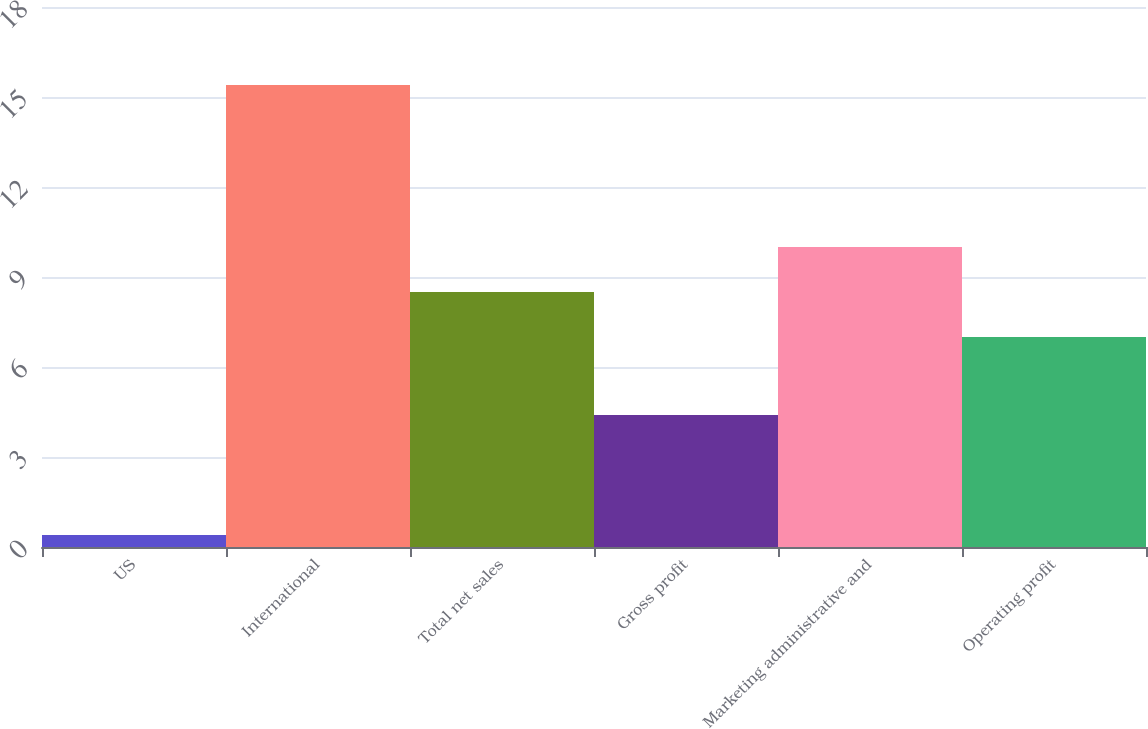Convert chart. <chart><loc_0><loc_0><loc_500><loc_500><bar_chart><fcel>US<fcel>International<fcel>Total net sales<fcel>Gross profit<fcel>Marketing administrative and<fcel>Operating profit<nl><fcel>0.4<fcel>15.4<fcel>8.5<fcel>4.4<fcel>10<fcel>7<nl></chart> 